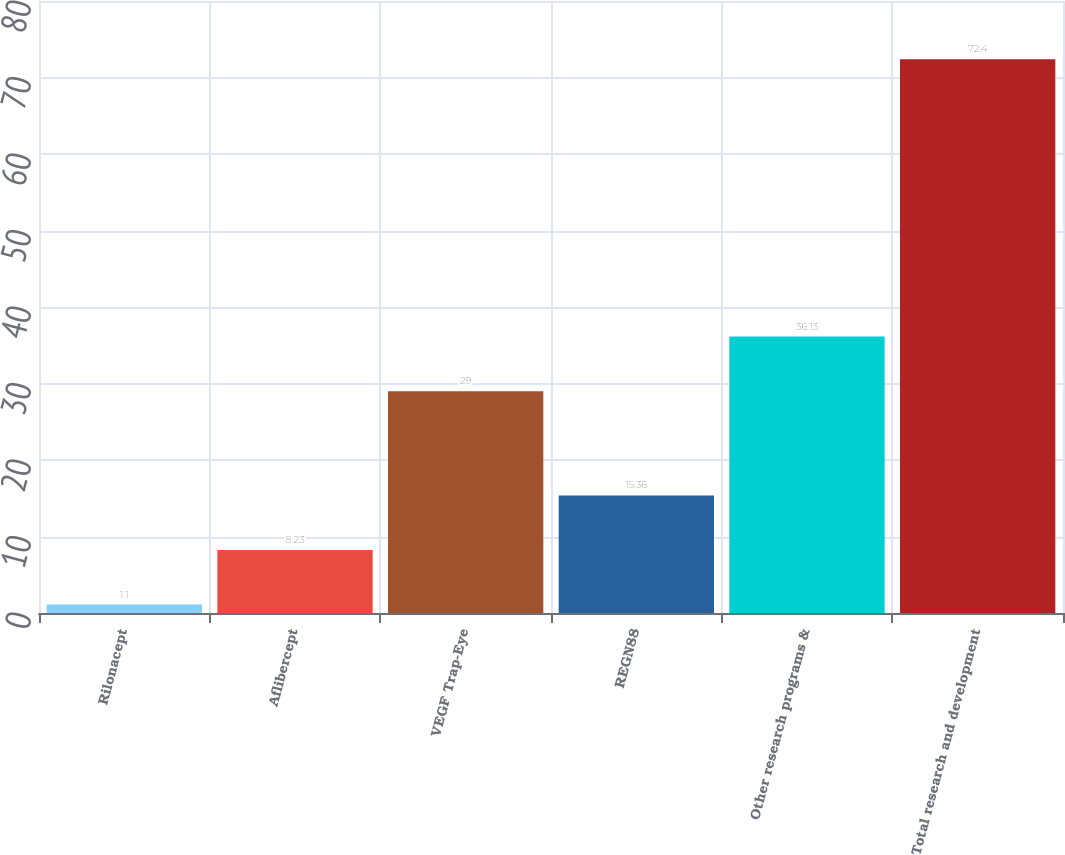Convert chart to OTSL. <chart><loc_0><loc_0><loc_500><loc_500><bar_chart><fcel>Rilonacept<fcel>Aflibercept<fcel>VEGF Trap-Eye<fcel>REGN88<fcel>Other research programs &<fcel>Total research and development<nl><fcel>1.1<fcel>8.23<fcel>29<fcel>15.36<fcel>36.13<fcel>72.4<nl></chart> 